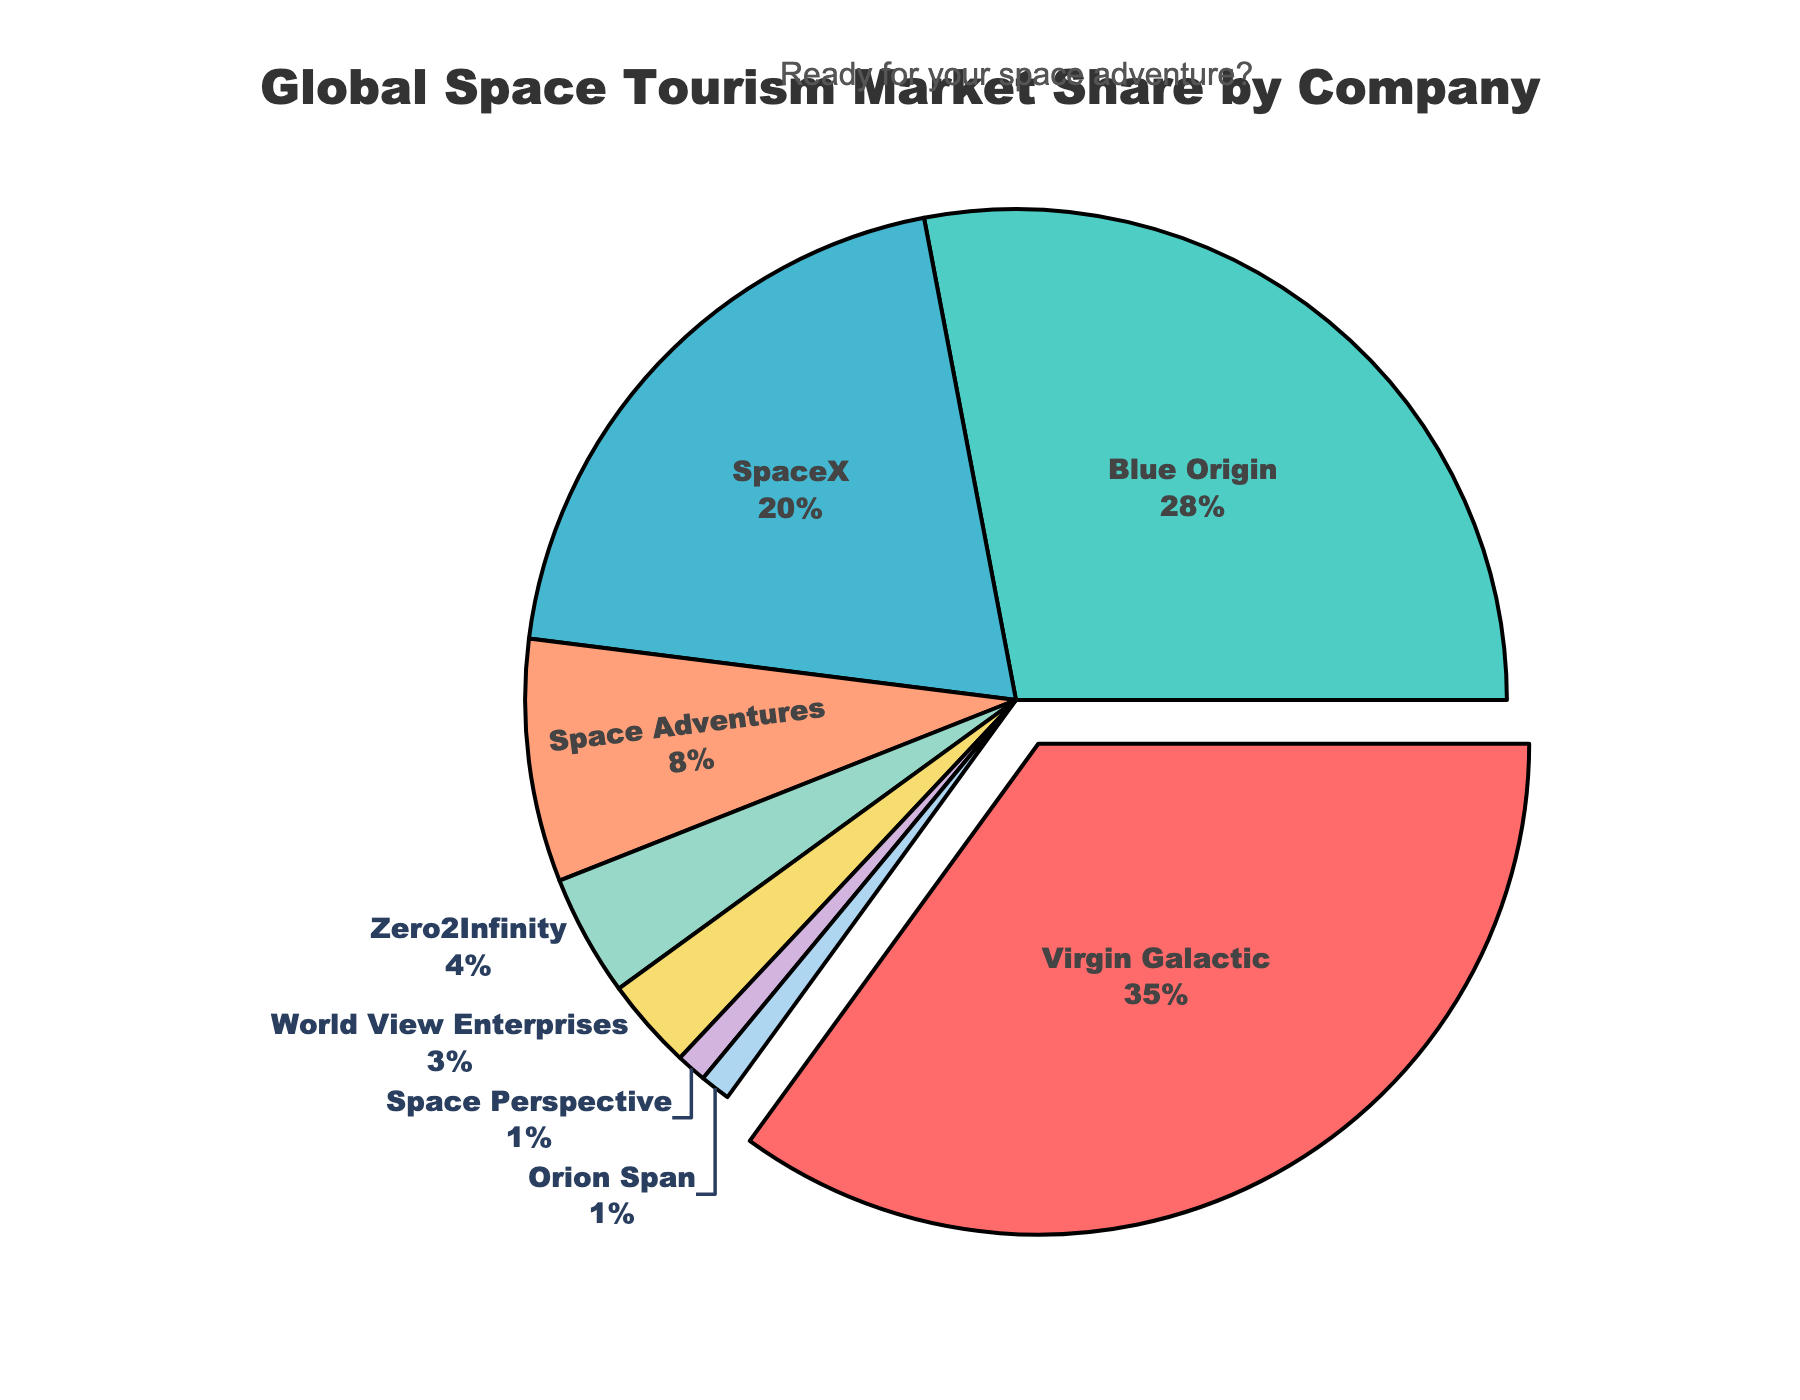What's the largest market share in the global space tourism market? The figure shows a pie chart where each slice represents the market share of a company. The slice with the highest percentage is for Virgin Galactic. The market share value for Virgin Galactic is 35%.
Answer: 35% Which company has the second-largest market share? To determine the company with the second-largest market share, look for the second-largest slice after Virgin Galactic. That slice represents Blue Origin, with a market share of 28%.
Answer: Blue Origin What is the combined market share of SpaceX and Space Adventures? To find the combined market share of SpaceX and Space Adventures, sum their respective market shares: SpaceX has 20% and Space Adventures has 8%. The combined market share is 20% + 8% = 28%.
Answer: 28% How much larger is Virgin Galactic's market share compared to Zero2Infinity's? Virgin Galactic has a market share of 35%, and Zero2Infinity has 4%. Subtract Zero2Infinity's share from Virgin Galactic's: 35% - 4% = 31%.
Answer: 31% Which company is represented by the smallest slice in the pie chart? To identify the company with the smallest slice, look for the smallest segment of the pie chart. The smallest market share is 1%, represented by both Space Perspective and Orion Span.
Answer: Space Perspective and Orion Span What percentage of the market is not covered by the top three companies? The top three companies are Virgin Galactic (35%), Blue Origin (28%), and SpaceX (20%). Their combined market share is 35% + 28% + 20% = 83%. The remaining market share is 100% - 83% = 17%.
Answer: 17% If you combine the market shares of the last four companies (Zero2Infinity, World View Enterprises, Space Perspective, and Orion Span), do they surpass SpaceX's market share? Add the market shares of the last four companies: Zero2Infinity (4%) + World View Enterprises (3%) + Space Perspective (1%) + Orion Span (1%) = 9%. Compare this to SpaceX's market share of 20%. 9% is less than 20%. Therefore, they do not surpass SpaceX's market share.
Answer: No Which companies have a market share of less than 5%? From the figure, list all companies with a market share of less than 5%. These companies are Space Adventures (8%), Zero2Infinity (4%), World View Enterprises (3%), Space Perspective (1%), and Orion Span (1%).
Answer: Zero2Infinity, World View Enterprises, Space Perspective, and Orion Span Among the companies with less than 5% market share, which one has the largest slice? Focus on companies with less than 5% market share and find the one with the largest percentage: Zero2Infinity has 4%, which is the largest among the companies in this range.
Answer: Zero2Infinity 